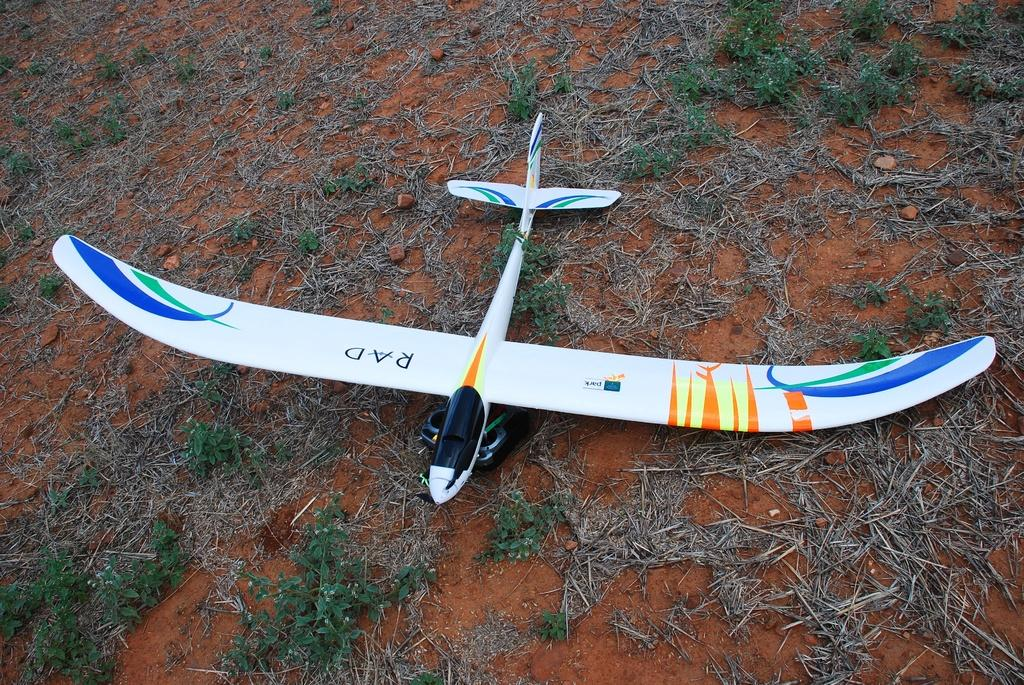What is the main subject of the image? The main subject of the image is an airplane. Where is the airplane located in the image? The airplane is on the ground in the image. What else can be seen in the image besides the airplane? There are plants visible in the image. What type of texture can be seen on the walls of the room in the image? There is no room present in the image; it features an airplane on the ground with plants nearby. 